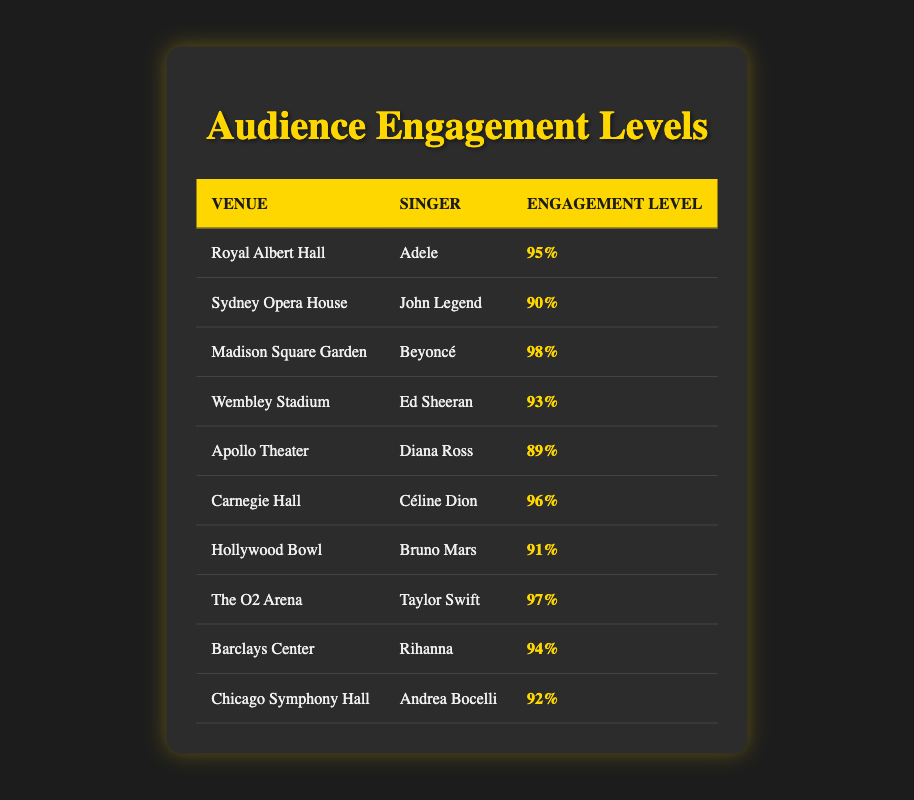What is the highest engagement level recorded in the table? The table shows the engagement levels for various singers and venues. Scanning through the engagement levels, the highest listed is 98%, which corresponds to the performance by Beyoncé at Madison Square Garden.
Answer: 98% Which singer had the lowest engagement level? Reviewing the engagement levels in the table, the lowest engagement level is 89%, associated with Diana Ross at the Apollo Theater.
Answer: 89% What is the average engagement level of the singers listed? To find the average, sum all the engagement levels: 95 + 90 + 98 + 93 + 89 + 96 + 91 + 97 + 94 + 92 = 925. Then divides by the number of entries (10) gives 925 / 10 = 92.5.
Answer: 92.5 Did Rihanna have a higher engagement level than Ed Sheeran? Looking at the engagement levels, Rihanna at Barclays Center has an engagement of 94% while Ed Sheeran at Wembley Stadium has 93%. Since 94% is greater than 93%, the answer is yes.
Answer: Yes How much higher is Beyoncé's engagement level compared to Diana Ross's? Beyoncé's engagement level is 98% and Diana Ross's is 89%. The difference is calculated by subtracting 89 from 98, which gives a difference of 9%.
Answer: 9% Which venue has the second-highest engagement level? First, organize the venues by their engagement levels in descending order: 
1. Madison Square Garden (98%)
2. The O2 Arena (97%)
3. Carnegie Hall (96%)
4. Royal Albert Hall (95%)
So, the second-highest engagement level is 97% at The O2 Arena with Taylor Swift.
Answer: The O2 Arena Is there any singer who performed in more than one venue listed in the table? Reviewing the table, each singer appears to have only one venue associated with them, so there are no singers that performed in more than one venue from this dataset.
Answer: No What is the total engagement level from all venues combined? To find the total engagement, sum the engagement levels of all singers: 95 + 90 + 98 + 93 + 89 + 96 + 91 + 97 + 94 + 92 = 925.
Answer: 925 